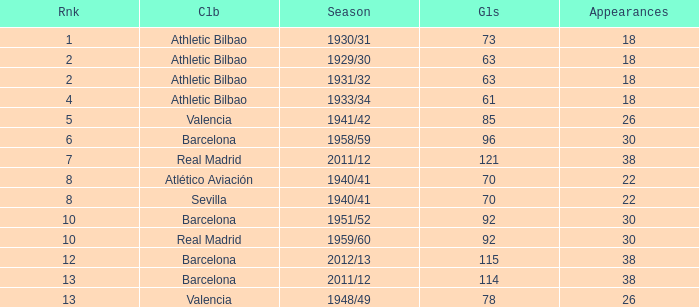How many apps when the ranking was post 13 and with more than 73 targets? None. 